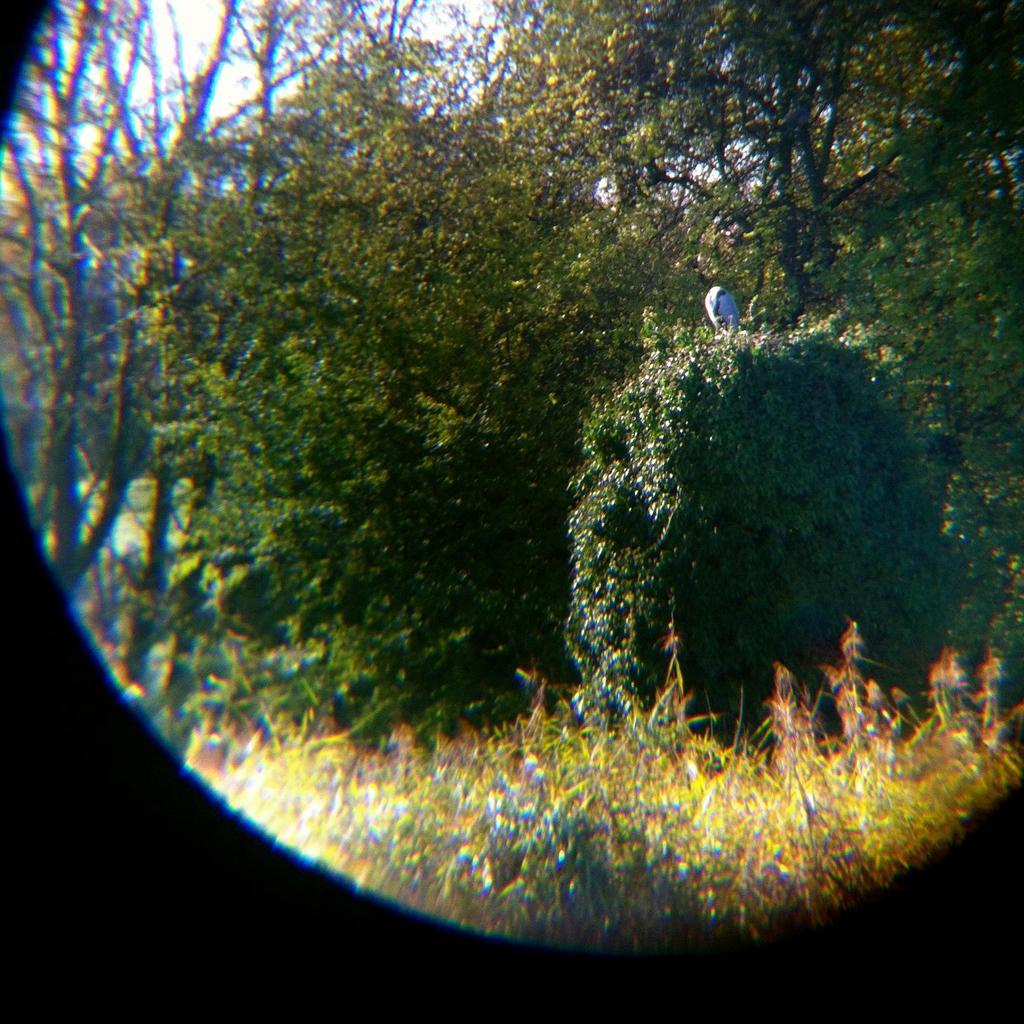Could you give a brief overview of what you see in this image? Here in this picture we can see plants and trees present on the ground all over there. 